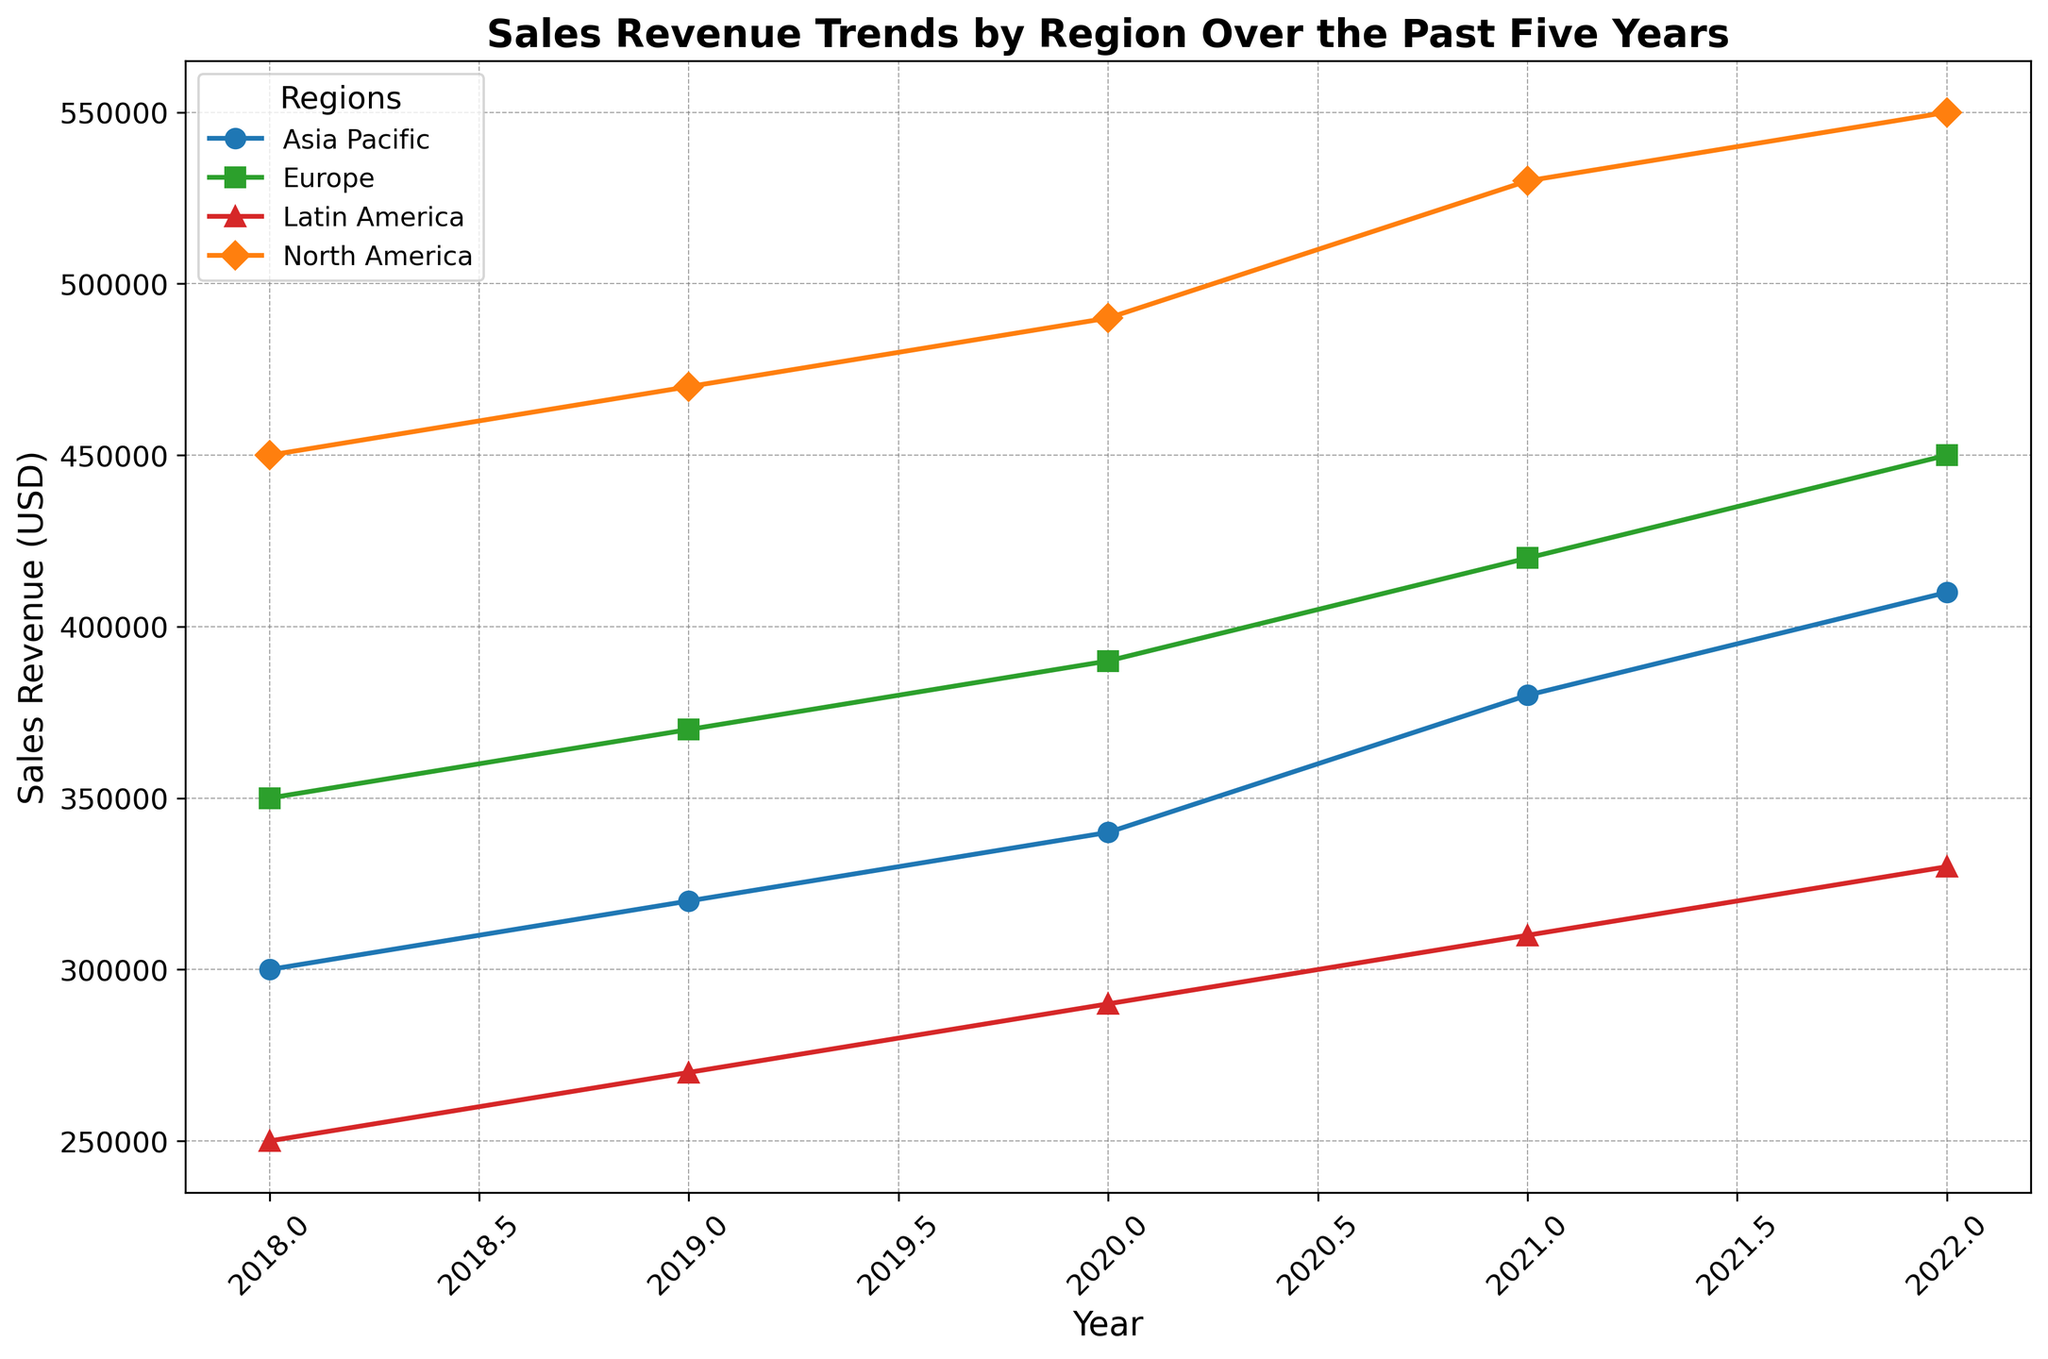What's the overall trend in sales revenue for North America over the past five years? North America's sales revenue shows a consistent annual increase over the past five years. Starting from 450,000 in 2018, it increases every year to reach 550,000 in 2022.
Answer: Consistent increase Which region had the smallest increase in sales revenue from 2018 to 2022? We need to find the difference between 2022 and 2018 sales revenue for each region. North America: 550,000 - 450,000 = 100,000, Europe: 450,000 - 350,000 = 100,000, Asia Pacific: 410,000 - 300,000 = 110,000, Latin America: 330,000 - 250,000 = 80,000. Latin America has the smallest increase.
Answer: Latin America Compare the sales revenue growth rate between Europe and Asia Pacific from 2018 to 2022. Which region had a higher growth rate? Calculate the growth rate for both regions. Europe: (450,000 - 350,000) / 350,000 = 0.286 or 28.6%, Asia Pacific: (410,000 - 300,000) / 300,000 = 0.367 or 36.7%. Asia Pacific has a higher growth rate.
Answer: Asia Pacific How does the sales revenue of Europe in 2021 compare to that in 2020? The sales revenue for Europe in 2020 was 390,000 and in 2021 it was 420,000. This is an increase of 420,000 - 390,000 = 30,000.
Answer: Increased by 30,000 Among the four regions, which one had the least sales revenue in 2018 and how did its 2022 sales revenue compare to the other regions in the same year? In 2018, Latin America had the least sales revenue with 250,000. In 2022, Latin America's sales revenue was 330,000, which is still the lowest compared to North America, Europe, and Asia Pacific in the same year.
Answer: Latin America, lowest in 2022 What is the average sales revenue for Asia Pacific over the past five years? Sum the sales revenues from 2018 to 2022 for Asia Pacific (300,000 + 320,000 + 340,000 + 380,000 + 410,000) = 1,750,000. Divide by 5 to get the average: 1,750,000 / 5 = 350,000.
Answer: 350,000 Which region shows the most consistent increase in sales revenue over the past five years based on the visual slope and smoothness of the line? North America's sales revenue line shows a smooth and consistent upward trend without any fluctuations, indicating the most consistent increase.
Answer: North America 